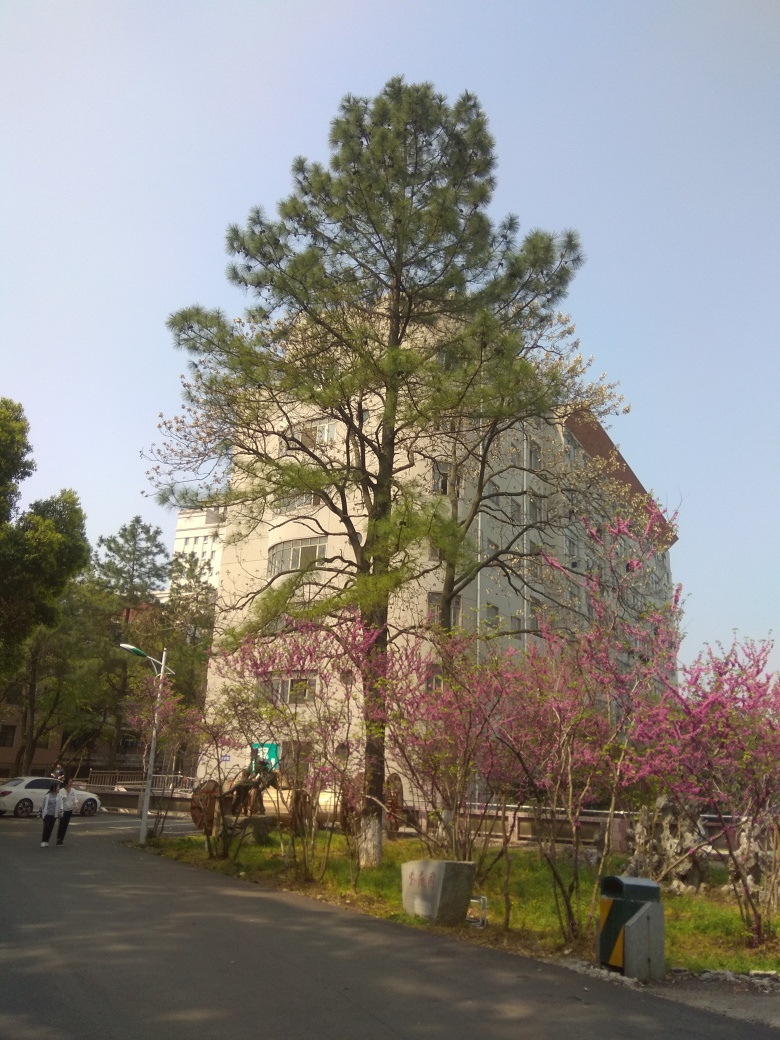Does this image give any clues about the season or time of year? Yes, the presence of blooming pink flowers on the smaller trees suggests that it is spring. These types of trees typically flower in the spring season before the full foliage appears. Additionally, the quality of the light and the lack of leaves on some trees further support the idea that the photo was taken in the springtime. 